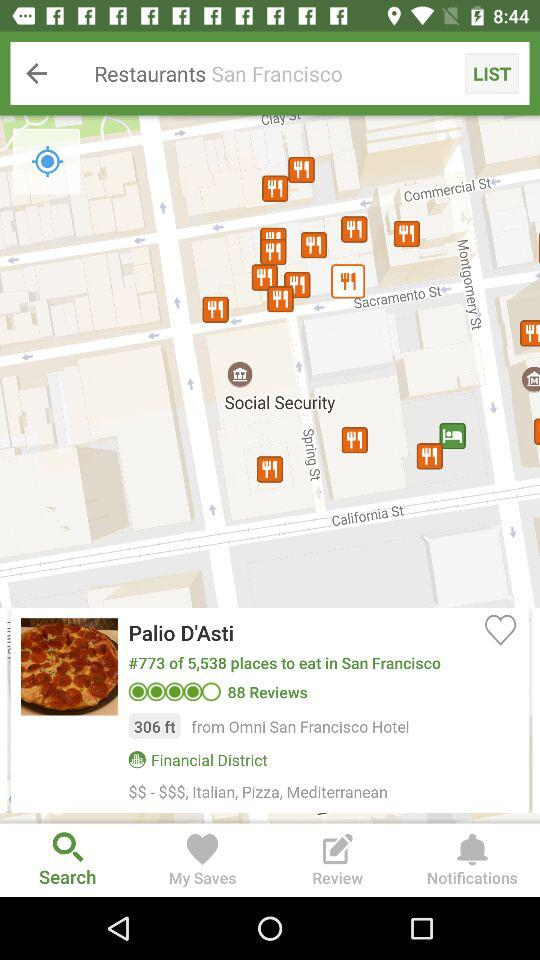How many reviews does Palio D'Asti have?
Answer the question using a single word or phrase. 88 